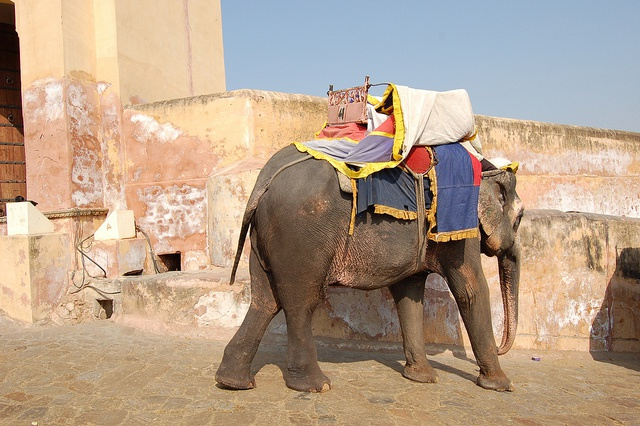Describe the objects in this image and their specific colors. I can see a elephant in maroon, gray, and black tones in this image. 